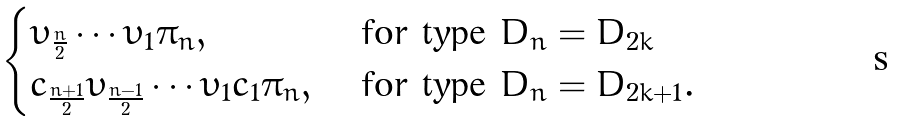Convert formula to latex. <formula><loc_0><loc_0><loc_500><loc_500>\begin{cases} \upsilon _ { \frac { n } { 2 } } \cdots \upsilon _ { 1 } \pi _ { n } , & \text { for type $D_{n}=D_{2k}$} \\ c _ { \frac { n + 1 } { 2 } } \upsilon _ { \frac { n - 1 } { 2 } } \cdots \upsilon _ { 1 } c _ { 1 } \pi _ { n } , & \text { for type $D_{n}=D_{2k+1}$} . \end{cases}</formula> 